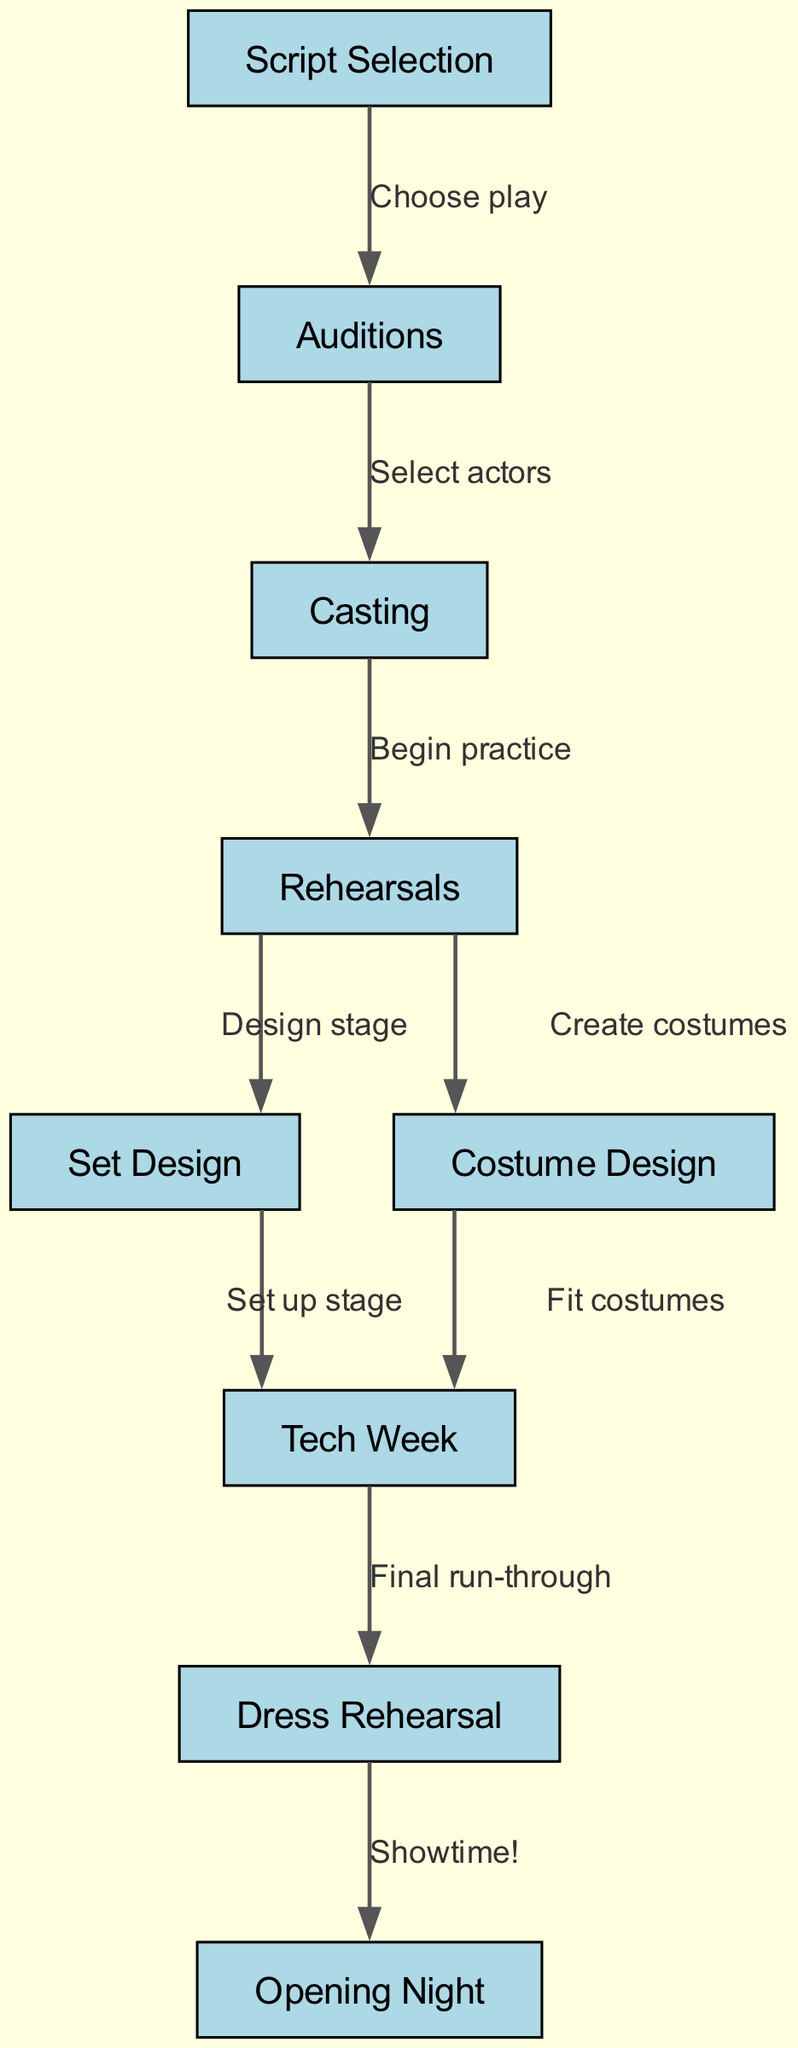What is the first step in the play production process? The first node in the diagram represents "Script Selection" which indicates that selecting a script is the initial step.
Answer: Script Selection How many nodes are present in the diagram? By counting all the distinct nodes, we can identify a total of nine key steps in the play production process.
Answer: 9 Which node comes immediately after "Casting"? Following the "Casting" node, the next step is "Rehearsals", indicating that practice begins after actors have been selected.
Answer: Rehearsals What is the connection between "Set Design" and "Tech Week"? "Set Design" leads to "Tech Week" as it indicates that setting up the stage is necessary before the technical rehearsals begin.
Answer: Set up stage What is the last step before "Opening Night"? The node directly before "Opening Night" is "Dress Rehearsal", which serves as the final practice before the actual performance.
Answer: Dress Rehearsal How do rehearsals contribute to set and costume design? "Rehearsals" branches out to both "Set Design" and "Costume Design", demonstrating that practicing includes the time for designing the stage and costumes.
Answer: Design stage and Create costumes What are the two major components that follow "Rehearsals"? After "Rehearsals", both "Set Design" and "Costume Design" are the two major components involved in the production process that proceed concurrently.
Answer: Set Design and Costume Design Which nodes are directly connected with an edge labeled "Final run-through"? The edge labeled "Final run-through" connects "Tech Week" to "Dress Rehearsal", indicating that the final practices are held during the tech week.
Answer: Tech Week and Dress Rehearsal What is the significance of "Auditions" in this process? "Auditions" is a crucial step where actors are selected, as shown by the edge that connects it to "Casting", thereby playing a key role in determining the cast for the play.
Answer: Select actors 